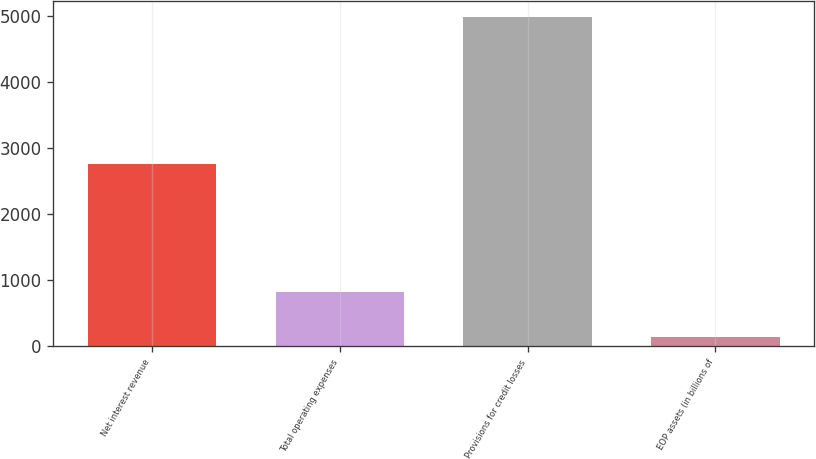<chart> <loc_0><loc_0><loc_500><loc_500><bar_chart><fcel>Net interest revenue<fcel>Total operating expenses<fcel>Provisions for credit losses<fcel>EOP assets (in billions of<nl><fcel>2754<fcel>824<fcel>4980<fcel>136<nl></chart> 